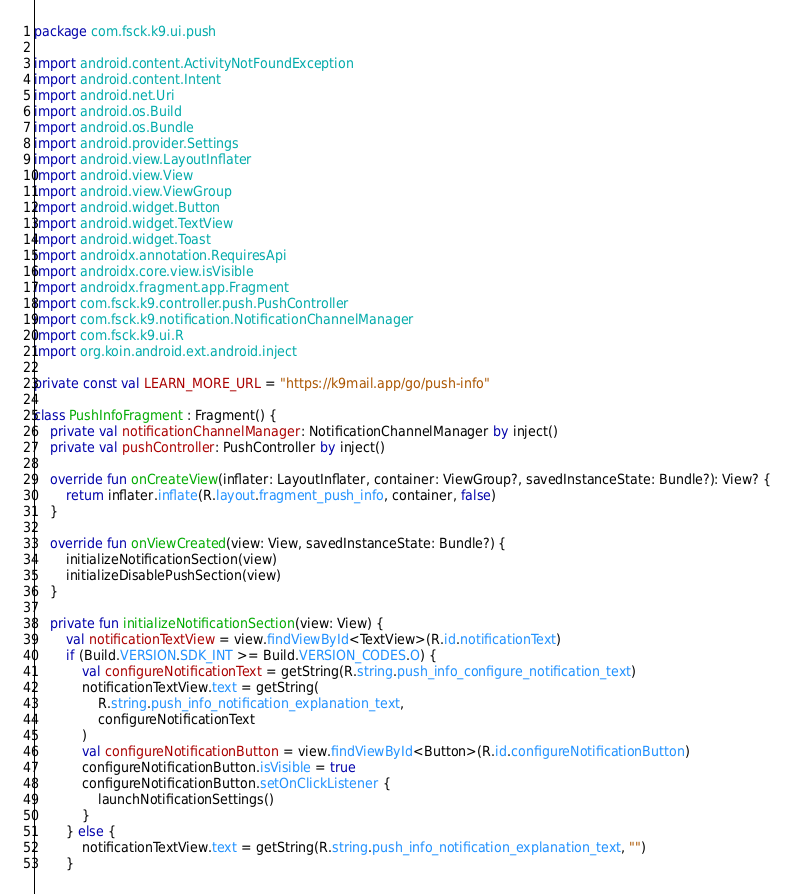Convert code to text. <code><loc_0><loc_0><loc_500><loc_500><_Kotlin_>package com.fsck.k9.ui.push

import android.content.ActivityNotFoundException
import android.content.Intent
import android.net.Uri
import android.os.Build
import android.os.Bundle
import android.provider.Settings
import android.view.LayoutInflater
import android.view.View
import android.view.ViewGroup
import android.widget.Button
import android.widget.TextView
import android.widget.Toast
import androidx.annotation.RequiresApi
import androidx.core.view.isVisible
import androidx.fragment.app.Fragment
import com.fsck.k9.controller.push.PushController
import com.fsck.k9.notification.NotificationChannelManager
import com.fsck.k9.ui.R
import org.koin.android.ext.android.inject

private const val LEARN_MORE_URL = "https://k9mail.app/go/push-info"

class PushInfoFragment : Fragment() {
    private val notificationChannelManager: NotificationChannelManager by inject()
    private val pushController: PushController by inject()

    override fun onCreateView(inflater: LayoutInflater, container: ViewGroup?, savedInstanceState: Bundle?): View? {
        return inflater.inflate(R.layout.fragment_push_info, container, false)
    }

    override fun onViewCreated(view: View, savedInstanceState: Bundle?) {
        initializeNotificationSection(view)
        initializeDisablePushSection(view)
    }

    private fun initializeNotificationSection(view: View) {
        val notificationTextView = view.findViewById<TextView>(R.id.notificationText)
        if (Build.VERSION.SDK_INT >= Build.VERSION_CODES.O) {
            val configureNotificationText = getString(R.string.push_info_configure_notification_text)
            notificationTextView.text = getString(
                R.string.push_info_notification_explanation_text,
                configureNotificationText
            )
            val configureNotificationButton = view.findViewById<Button>(R.id.configureNotificationButton)
            configureNotificationButton.isVisible = true
            configureNotificationButton.setOnClickListener {
                launchNotificationSettings()
            }
        } else {
            notificationTextView.text = getString(R.string.push_info_notification_explanation_text, "")
        }
</code> 